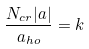Convert formula to latex. <formula><loc_0><loc_0><loc_500><loc_500>\frac { N _ { c r } | a | } { a _ { h o } } = k</formula> 